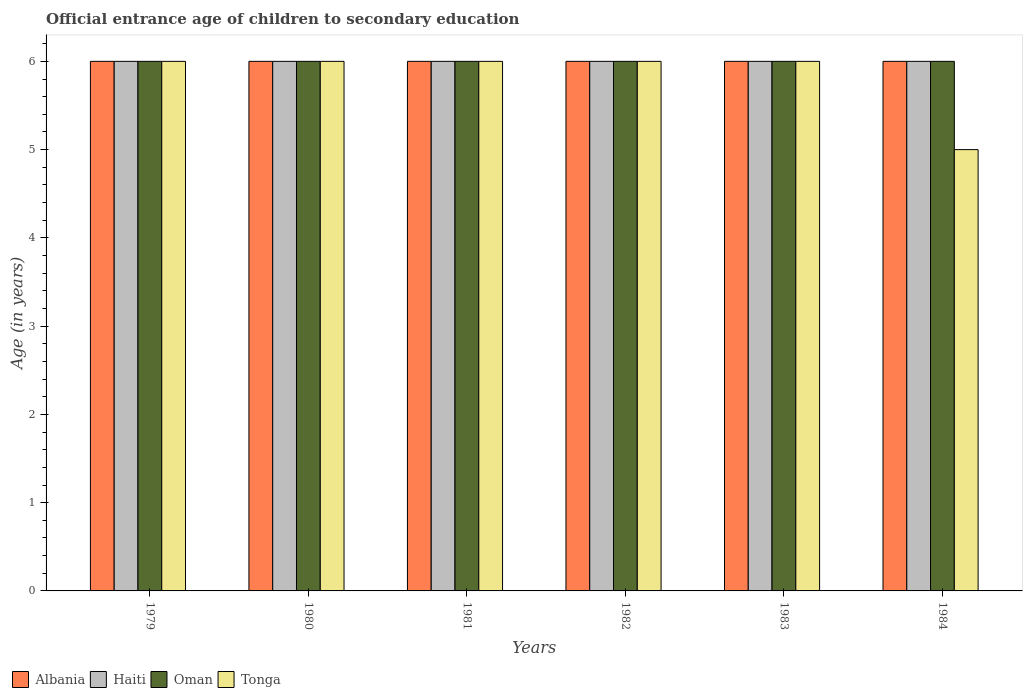Are the number of bars per tick equal to the number of legend labels?
Keep it short and to the point. Yes. How many bars are there on the 6th tick from the right?
Ensure brevity in your answer.  4. What is the label of the 1st group of bars from the left?
Your response must be concise. 1979. What is the secondary school starting age of children in Haiti in 1980?
Your response must be concise. 6. Across all years, what is the minimum secondary school starting age of children in Tonga?
Offer a very short reply. 5. In which year was the secondary school starting age of children in Haiti maximum?
Provide a succinct answer. 1979. In which year was the secondary school starting age of children in Oman minimum?
Provide a succinct answer. 1979. What is the total secondary school starting age of children in Haiti in the graph?
Your response must be concise. 36. What is the difference between the secondary school starting age of children in Albania in 1982 and that in 1983?
Provide a succinct answer. 0. What is the difference between the secondary school starting age of children in Haiti in 1979 and the secondary school starting age of children in Oman in 1980?
Offer a terse response. 0. What is the average secondary school starting age of children in Albania per year?
Offer a terse response. 6. In the year 1982, what is the difference between the secondary school starting age of children in Tonga and secondary school starting age of children in Albania?
Your response must be concise. 0. In how many years, is the secondary school starting age of children in Tonga greater than 4.8 years?
Keep it short and to the point. 6. Is the secondary school starting age of children in Tonga in 1979 less than that in 1981?
Offer a terse response. No. Is the difference between the secondary school starting age of children in Tonga in 1982 and 1984 greater than the difference between the secondary school starting age of children in Albania in 1982 and 1984?
Your answer should be very brief. Yes. What is the difference between the highest and the second highest secondary school starting age of children in Tonga?
Offer a very short reply. 0. In how many years, is the secondary school starting age of children in Albania greater than the average secondary school starting age of children in Albania taken over all years?
Provide a succinct answer. 0. What does the 2nd bar from the left in 1981 represents?
Keep it short and to the point. Haiti. What does the 3rd bar from the right in 1984 represents?
Keep it short and to the point. Haiti. How many bars are there?
Your response must be concise. 24. How many years are there in the graph?
Ensure brevity in your answer.  6. What is the difference between two consecutive major ticks on the Y-axis?
Provide a succinct answer. 1. Are the values on the major ticks of Y-axis written in scientific E-notation?
Provide a short and direct response. No. Does the graph contain any zero values?
Make the answer very short. No. Where does the legend appear in the graph?
Your response must be concise. Bottom left. How many legend labels are there?
Your answer should be very brief. 4. How are the legend labels stacked?
Your response must be concise. Horizontal. What is the title of the graph?
Your answer should be very brief. Official entrance age of children to secondary education. What is the label or title of the Y-axis?
Offer a very short reply. Age (in years). What is the Age (in years) in Haiti in 1979?
Offer a terse response. 6. What is the Age (in years) of Oman in 1979?
Provide a succinct answer. 6. What is the Age (in years) in Haiti in 1980?
Give a very brief answer. 6. What is the Age (in years) in Oman in 1980?
Offer a terse response. 6. What is the Age (in years) in Albania in 1981?
Your answer should be compact. 6. What is the Age (in years) of Haiti in 1981?
Your response must be concise. 6. What is the Age (in years) in Oman in 1981?
Ensure brevity in your answer.  6. What is the Age (in years) of Tonga in 1981?
Ensure brevity in your answer.  6. What is the Age (in years) of Albania in 1982?
Provide a short and direct response. 6. What is the Age (in years) in Haiti in 1982?
Keep it short and to the point. 6. What is the Age (in years) of Oman in 1983?
Offer a very short reply. 6. What is the Age (in years) in Albania in 1984?
Ensure brevity in your answer.  6. What is the Age (in years) of Oman in 1984?
Provide a succinct answer. 6. What is the Age (in years) of Tonga in 1984?
Provide a short and direct response. 5. Across all years, what is the maximum Age (in years) of Albania?
Offer a terse response. 6. Across all years, what is the maximum Age (in years) in Haiti?
Offer a terse response. 6. Across all years, what is the maximum Age (in years) in Tonga?
Provide a succinct answer. 6. Across all years, what is the minimum Age (in years) of Albania?
Give a very brief answer. 6. What is the total Age (in years) of Albania in the graph?
Give a very brief answer. 36. What is the difference between the Age (in years) of Albania in 1979 and that in 1980?
Your answer should be very brief. 0. What is the difference between the Age (in years) of Haiti in 1979 and that in 1980?
Ensure brevity in your answer.  0. What is the difference between the Age (in years) of Oman in 1979 and that in 1980?
Provide a succinct answer. 0. What is the difference between the Age (in years) in Tonga in 1979 and that in 1981?
Offer a very short reply. 0. What is the difference between the Age (in years) in Albania in 1979 and that in 1982?
Offer a very short reply. 0. What is the difference between the Age (in years) in Oman in 1979 and that in 1982?
Your answer should be very brief. 0. What is the difference between the Age (in years) of Tonga in 1979 and that in 1982?
Make the answer very short. 0. What is the difference between the Age (in years) in Haiti in 1979 and that in 1983?
Make the answer very short. 0. What is the difference between the Age (in years) in Oman in 1979 and that in 1983?
Make the answer very short. 0. What is the difference between the Age (in years) of Tonga in 1979 and that in 1983?
Your answer should be very brief. 0. What is the difference between the Age (in years) in Albania in 1979 and that in 1984?
Your response must be concise. 0. What is the difference between the Age (in years) of Oman in 1979 and that in 1984?
Offer a terse response. 0. What is the difference between the Age (in years) of Tonga in 1979 and that in 1984?
Offer a terse response. 1. What is the difference between the Age (in years) of Albania in 1980 and that in 1981?
Keep it short and to the point. 0. What is the difference between the Age (in years) of Oman in 1980 and that in 1981?
Provide a short and direct response. 0. What is the difference between the Age (in years) of Haiti in 1980 and that in 1982?
Make the answer very short. 0. What is the difference between the Age (in years) in Oman in 1980 and that in 1982?
Offer a terse response. 0. What is the difference between the Age (in years) in Haiti in 1980 and that in 1984?
Make the answer very short. 0. What is the difference between the Age (in years) in Albania in 1981 and that in 1982?
Ensure brevity in your answer.  0. What is the difference between the Age (in years) of Haiti in 1981 and that in 1982?
Ensure brevity in your answer.  0. What is the difference between the Age (in years) in Haiti in 1981 and that in 1983?
Offer a terse response. 0. What is the difference between the Age (in years) in Oman in 1981 and that in 1983?
Keep it short and to the point. 0. What is the difference between the Age (in years) in Tonga in 1981 and that in 1983?
Provide a succinct answer. 0. What is the difference between the Age (in years) of Albania in 1981 and that in 1984?
Your answer should be very brief. 0. What is the difference between the Age (in years) in Haiti in 1981 and that in 1984?
Make the answer very short. 0. What is the difference between the Age (in years) of Albania in 1982 and that in 1983?
Give a very brief answer. 0. What is the difference between the Age (in years) of Haiti in 1982 and that in 1983?
Provide a short and direct response. 0. What is the difference between the Age (in years) of Oman in 1982 and that in 1983?
Your response must be concise. 0. What is the difference between the Age (in years) of Tonga in 1982 and that in 1983?
Provide a short and direct response. 0. What is the difference between the Age (in years) in Haiti in 1983 and that in 1984?
Offer a terse response. 0. What is the difference between the Age (in years) in Oman in 1983 and that in 1984?
Your answer should be very brief. 0. What is the difference between the Age (in years) of Albania in 1979 and the Age (in years) of Haiti in 1980?
Your response must be concise. 0. What is the difference between the Age (in years) of Albania in 1979 and the Age (in years) of Oman in 1980?
Keep it short and to the point. 0. What is the difference between the Age (in years) in Haiti in 1979 and the Age (in years) in Tonga in 1980?
Your answer should be compact. 0. What is the difference between the Age (in years) in Oman in 1979 and the Age (in years) in Tonga in 1980?
Provide a succinct answer. 0. What is the difference between the Age (in years) of Haiti in 1979 and the Age (in years) of Tonga in 1981?
Offer a terse response. 0. What is the difference between the Age (in years) in Albania in 1979 and the Age (in years) in Tonga in 1982?
Provide a short and direct response. 0. What is the difference between the Age (in years) of Haiti in 1979 and the Age (in years) of Oman in 1982?
Offer a very short reply. 0. What is the difference between the Age (in years) of Haiti in 1979 and the Age (in years) of Tonga in 1982?
Offer a terse response. 0. What is the difference between the Age (in years) in Oman in 1979 and the Age (in years) in Tonga in 1982?
Keep it short and to the point. 0. What is the difference between the Age (in years) in Albania in 1979 and the Age (in years) in Haiti in 1983?
Ensure brevity in your answer.  0. What is the difference between the Age (in years) of Albania in 1979 and the Age (in years) of Oman in 1983?
Make the answer very short. 0. What is the difference between the Age (in years) of Albania in 1979 and the Age (in years) of Tonga in 1983?
Offer a terse response. 0. What is the difference between the Age (in years) in Haiti in 1979 and the Age (in years) in Oman in 1983?
Offer a terse response. 0. What is the difference between the Age (in years) of Albania in 1979 and the Age (in years) of Oman in 1984?
Your response must be concise. 0. What is the difference between the Age (in years) of Haiti in 1979 and the Age (in years) of Oman in 1984?
Ensure brevity in your answer.  0. What is the difference between the Age (in years) of Haiti in 1979 and the Age (in years) of Tonga in 1984?
Offer a terse response. 1. What is the difference between the Age (in years) of Albania in 1980 and the Age (in years) of Haiti in 1981?
Ensure brevity in your answer.  0. What is the difference between the Age (in years) of Haiti in 1980 and the Age (in years) of Tonga in 1981?
Your answer should be compact. 0. What is the difference between the Age (in years) of Albania in 1980 and the Age (in years) of Haiti in 1982?
Give a very brief answer. 0. What is the difference between the Age (in years) of Albania in 1980 and the Age (in years) of Oman in 1982?
Provide a succinct answer. 0. What is the difference between the Age (in years) of Haiti in 1980 and the Age (in years) of Oman in 1982?
Offer a terse response. 0. What is the difference between the Age (in years) in Haiti in 1980 and the Age (in years) in Tonga in 1982?
Make the answer very short. 0. What is the difference between the Age (in years) in Albania in 1980 and the Age (in years) in Haiti in 1983?
Keep it short and to the point. 0. What is the difference between the Age (in years) of Albania in 1980 and the Age (in years) of Oman in 1983?
Ensure brevity in your answer.  0. What is the difference between the Age (in years) of Haiti in 1980 and the Age (in years) of Oman in 1983?
Your answer should be very brief. 0. What is the difference between the Age (in years) of Albania in 1980 and the Age (in years) of Haiti in 1984?
Your response must be concise. 0. What is the difference between the Age (in years) in Albania in 1980 and the Age (in years) in Tonga in 1984?
Your response must be concise. 1. What is the difference between the Age (in years) in Haiti in 1980 and the Age (in years) in Oman in 1984?
Give a very brief answer. 0. What is the difference between the Age (in years) in Oman in 1980 and the Age (in years) in Tonga in 1984?
Make the answer very short. 1. What is the difference between the Age (in years) of Albania in 1981 and the Age (in years) of Haiti in 1982?
Your answer should be compact. 0. What is the difference between the Age (in years) in Albania in 1981 and the Age (in years) in Tonga in 1982?
Offer a very short reply. 0. What is the difference between the Age (in years) in Albania in 1981 and the Age (in years) in Tonga in 1983?
Offer a very short reply. 0. What is the difference between the Age (in years) of Haiti in 1981 and the Age (in years) of Oman in 1983?
Provide a short and direct response. 0. What is the difference between the Age (in years) of Oman in 1981 and the Age (in years) of Tonga in 1983?
Provide a short and direct response. 0. What is the difference between the Age (in years) in Albania in 1981 and the Age (in years) in Oman in 1984?
Make the answer very short. 0. What is the difference between the Age (in years) of Albania in 1981 and the Age (in years) of Tonga in 1984?
Ensure brevity in your answer.  1. What is the difference between the Age (in years) of Haiti in 1981 and the Age (in years) of Tonga in 1984?
Provide a short and direct response. 1. What is the difference between the Age (in years) in Oman in 1981 and the Age (in years) in Tonga in 1984?
Give a very brief answer. 1. What is the difference between the Age (in years) in Albania in 1982 and the Age (in years) in Haiti in 1983?
Offer a terse response. 0. What is the difference between the Age (in years) of Albania in 1982 and the Age (in years) of Tonga in 1983?
Keep it short and to the point. 0. What is the difference between the Age (in years) of Haiti in 1982 and the Age (in years) of Tonga in 1983?
Give a very brief answer. 0. What is the difference between the Age (in years) in Haiti in 1982 and the Age (in years) in Tonga in 1984?
Provide a short and direct response. 1. What is the difference between the Age (in years) in Albania in 1983 and the Age (in years) in Tonga in 1984?
Your answer should be compact. 1. What is the difference between the Age (in years) in Haiti in 1983 and the Age (in years) in Oman in 1984?
Your answer should be very brief. 0. What is the difference between the Age (in years) of Haiti in 1983 and the Age (in years) of Tonga in 1984?
Make the answer very short. 1. What is the difference between the Age (in years) of Oman in 1983 and the Age (in years) of Tonga in 1984?
Offer a very short reply. 1. What is the average Age (in years) in Oman per year?
Offer a very short reply. 6. What is the average Age (in years) in Tonga per year?
Your answer should be compact. 5.83. In the year 1979, what is the difference between the Age (in years) of Albania and Age (in years) of Haiti?
Make the answer very short. 0. In the year 1979, what is the difference between the Age (in years) of Albania and Age (in years) of Oman?
Provide a short and direct response. 0. In the year 1979, what is the difference between the Age (in years) of Albania and Age (in years) of Tonga?
Your answer should be compact. 0. In the year 1979, what is the difference between the Age (in years) in Haiti and Age (in years) in Tonga?
Give a very brief answer. 0. In the year 1979, what is the difference between the Age (in years) in Oman and Age (in years) in Tonga?
Keep it short and to the point. 0. In the year 1980, what is the difference between the Age (in years) in Albania and Age (in years) in Haiti?
Ensure brevity in your answer.  0. In the year 1980, what is the difference between the Age (in years) of Albania and Age (in years) of Oman?
Your response must be concise. 0. In the year 1980, what is the difference between the Age (in years) of Albania and Age (in years) of Tonga?
Make the answer very short. 0. In the year 1980, what is the difference between the Age (in years) of Haiti and Age (in years) of Oman?
Provide a short and direct response. 0. In the year 1981, what is the difference between the Age (in years) in Albania and Age (in years) in Haiti?
Provide a short and direct response. 0. In the year 1981, what is the difference between the Age (in years) in Haiti and Age (in years) in Oman?
Make the answer very short. 0. In the year 1981, what is the difference between the Age (in years) of Oman and Age (in years) of Tonga?
Make the answer very short. 0. In the year 1982, what is the difference between the Age (in years) in Albania and Age (in years) in Haiti?
Ensure brevity in your answer.  0. In the year 1982, what is the difference between the Age (in years) of Albania and Age (in years) of Oman?
Your answer should be compact. 0. In the year 1982, what is the difference between the Age (in years) of Haiti and Age (in years) of Oman?
Provide a short and direct response. 0. In the year 1982, what is the difference between the Age (in years) in Oman and Age (in years) in Tonga?
Your answer should be compact. 0. In the year 1983, what is the difference between the Age (in years) of Albania and Age (in years) of Oman?
Your answer should be very brief. 0. In the year 1983, what is the difference between the Age (in years) of Albania and Age (in years) of Tonga?
Keep it short and to the point. 0. In the year 1983, what is the difference between the Age (in years) of Haiti and Age (in years) of Tonga?
Keep it short and to the point. 0. In the year 1983, what is the difference between the Age (in years) of Oman and Age (in years) of Tonga?
Give a very brief answer. 0. In the year 1984, what is the difference between the Age (in years) of Albania and Age (in years) of Haiti?
Make the answer very short. 0. In the year 1984, what is the difference between the Age (in years) of Albania and Age (in years) of Tonga?
Your answer should be compact. 1. In the year 1984, what is the difference between the Age (in years) in Haiti and Age (in years) in Oman?
Offer a terse response. 0. What is the ratio of the Age (in years) of Haiti in 1979 to that in 1980?
Your answer should be very brief. 1. What is the ratio of the Age (in years) in Tonga in 1979 to that in 1980?
Your response must be concise. 1. What is the ratio of the Age (in years) of Albania in 1979 to that in 1981?
Provide a short and direct response. 1. What is the ratio of the Age (in years) in Haiti in 1979 to that in 1981?
Provide a short and direct response. 1. What is the ratio of the Age (in years) in Oman in 1979 to that in 1981?
Your response must be concise. 1. What is the ratio of the Age (in years) of Oman in 1979 to that in 1982?
Provide a short and direct response. 1. What is the ratio of the Age (in years) in Tonga in 1979 to that in 1982?
Provide a short and direct response. 1. What is the ratio of the Age (in years) in Albania in 1979 to that in 1983?
Your response must be concise. 1. What is the ratio of the Age (in years) in Tonga in 1979 to that in 1983?
Give a very brief answer. 1. What is the ratio of the Age (in years) of Albania in 1979 to that in 1984?
Provide a succinct answer. 1. What is the ratio of the Age (in years) in Albania in 1980 to that in 1981?
Your response must be concise. 1. What is the ratio of the Age (in years) in Haiti in 1980 to that in 1981?
Your answer should be compact. 1. What is the ratio of the Age (in years) in Tonga in 1980 to that in 1981?
Provide a succinct answer. 1. What is the ratio of the Age (in years) of Haiti in 1980 to that in 1983?
Offer a very short reply. 1. What is the ratio of the Age (in years) of Albania in 1981 to that in 1982?
Your response must be concise. 1. What is the ratio of the Age (in years) of Oman in 1981 to that in 1982?
Offer a terse response. 1. What is the ratio of the Age (in years) of Tonga in 1981 to that in 1982?
Provide a short and direct response. 1. What is the ratio of the Age (in years) in Albania in 1981 to that in 1983?
Ensure brevity in your answer.  1. What is the ratio of the Age (in years) in Albania in 1981 to that in 1984?
Offer a terse response. 1. What is the ratio of the Age (in years) in Haiti in 1981 to that in 1984?
Provide a succinct answer. 1. What is the ratio of the Age (in years) of Oman in 1981 to that in 1984?
Keep it short and to the point. 1. What is the ratio of the Age (in years) of Albania in 1982 to that in 1983?
Provide a short and direct response. 1. What is the ratio of the Age (in years) of Haiti in 1982 to that in 1983?
Your answer should be very brief. 1. What is the ratio of the Age (in years) of Oman in 1982 to that in 1983?
Your response must be concise. 1. What is the ratio of the Age (in years) of Albania in 1982 to that in 1984?
Your answer should be very brief. 1. What is the ratio of the Age (in years) in Haiti in 1982 to that in 1984?
Ensure brevity in your answer.  1. What is the ratio of the Age (in years) in Albania in 1983 to that in 1984?
Ensure brevity in your answer.  1. What is the ratio of the Age (in years) of Oman in 1983 to that in 1984?
Ensure brevity in your answer.  1. What is the difference between the highest and the second highest Age (in years) of Oman?
Offer a terse response. 0. What is the difference between the highest and the lowest Age (in years) in Albania?
Offer a terse response. 0. 